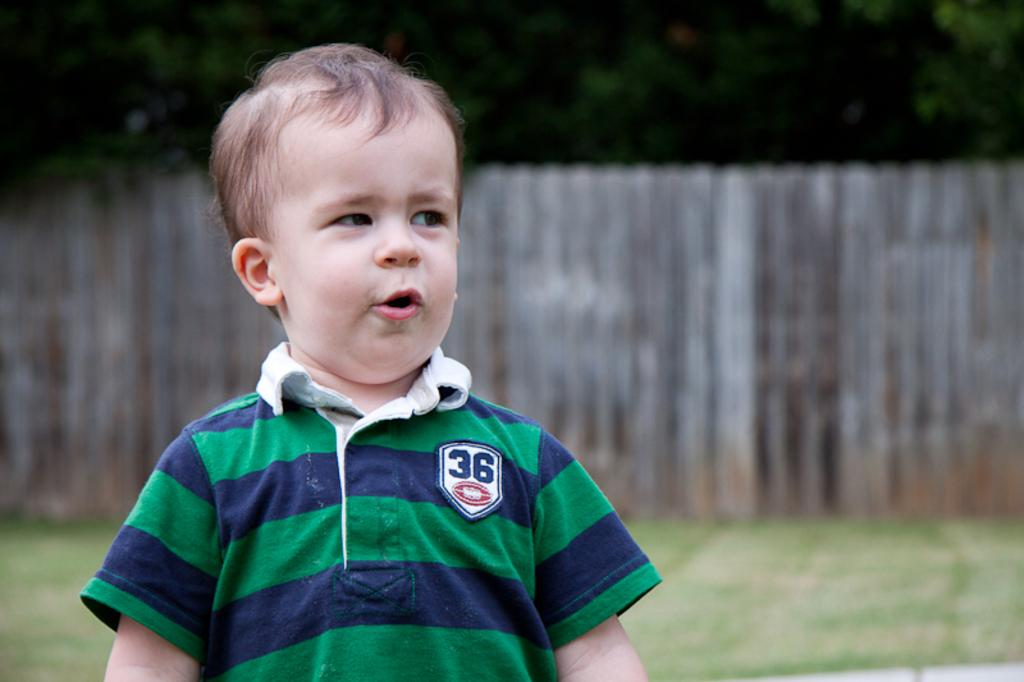What is the main subject of the image? There is a boy standing in the image. What can be seen in the background of the image? There is grass, a wooden fence, and trees in the background of the image. What type of religion is being practiced by the boy in the image? There is no indication of any religious practice in the image; it simply shows a boy standing in a natural setting. 